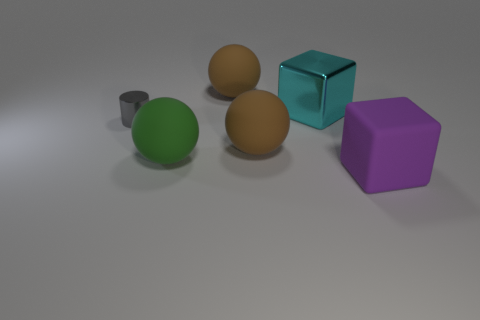How many cyan things are either big shiny things or metallic cylinders?
Your response must be concise. 1. Are there any green rubber balls of the same size as the green rubber object?
Provide a succinct answer. No. What is the material of the other cyan cube that is the same size as the matte block?
Provide a short and direct response. Metal. There is a brown matte thing that is in front of the large metal thing; is its size the same as the object that is on the left side of the green matte ball?
Offer a very short reply. No. What number of objects are either matte objects or brown matte things that are in front of the gray object?
Keep it short and to the point. 4. Are there any other big rubber objects of the same shape as the big cyan thing?
Your answer should be very brief. Yes. What is the size of the brown thing behind the big brown matte object in front of the cyan thing?
Your response must be concise. Large. What number of metallic objects are purple blocks or things?
Provide a succinct answer. 2. How many balls are there?
Offer a terse response. 3. Are the brown object that is behind the gray thing and the big block that is behind the tiny shiny cylinder made of the same material?
Keep it short and to the point. No. 